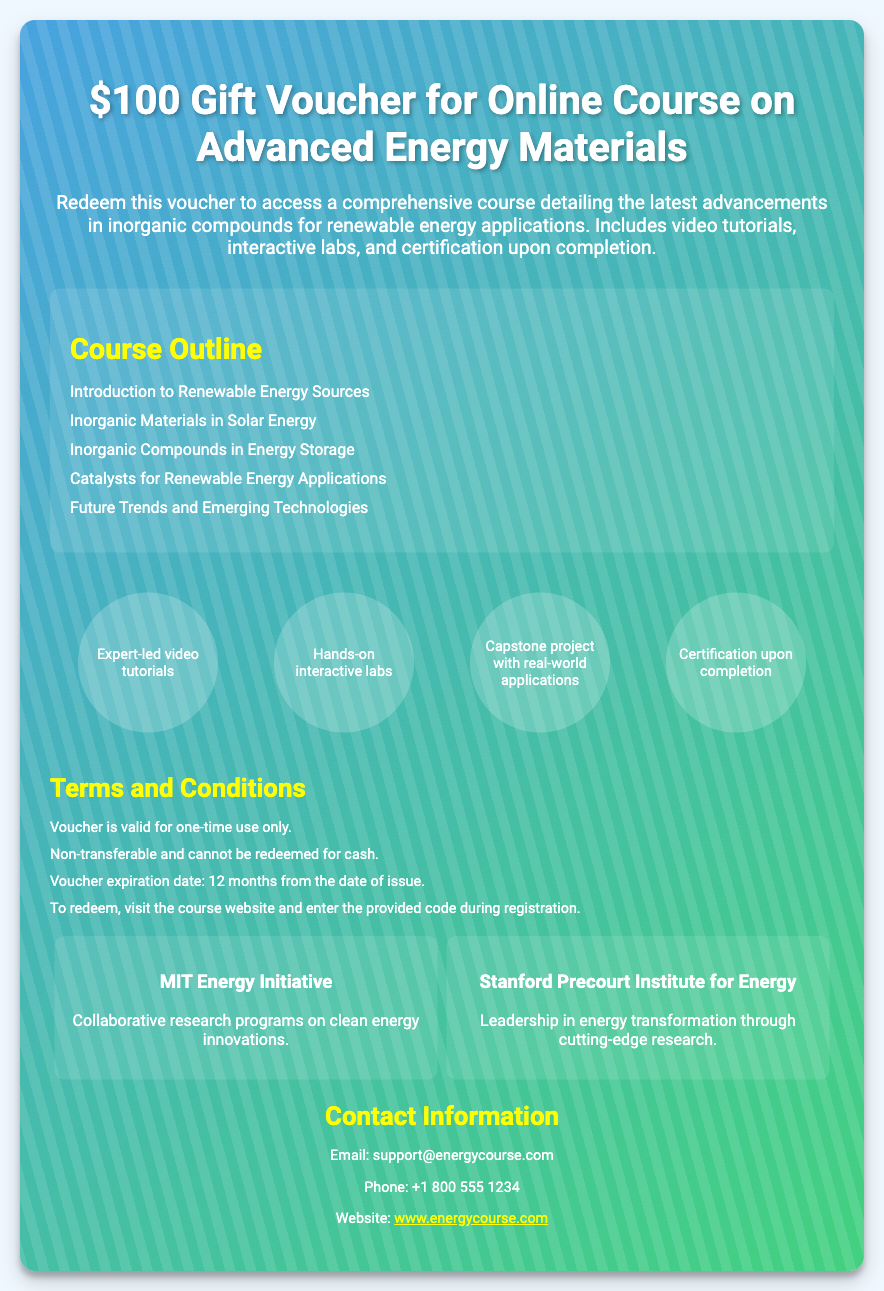What is the value of the voucher? The value of the voucher is stated prominently at the top of the document.
Answer: $100 What type of course does the voucher provide access to? The specific course that the voucher allows access to is mentioned in the description.
Answer: Online Course on Advanced Energy Materials What is included in the course? The description outlines what participants will receive when they redeem the voucher.
Answer: video tutorials, interactive labs, and certification How long is the voucher valid for? The terms and conditions specify the validity period of the voucher.
Answer: 12 months from the date of issue Which institution is mentioned alongside the course? The document mentions a specific institution related to energy studies.
Answer: MIT Energy Initiative What is one topic covered in the course? The course outline lists various topics that will be covered during the course.
Answer: Inorganic Materials in Solar Energy What is required to redeem the voucher? The terms section describes the process to redeem the voucher.
Answer: Enter the provided code during registration What is the phone number for contact? The contact information section provides a phone number for inquiries.
Answer: +1 800 555 1234 What is the capstone project designed to entail? The features section mentions an aspect of the course concerning real-world applications.
Answer: real-world applications 